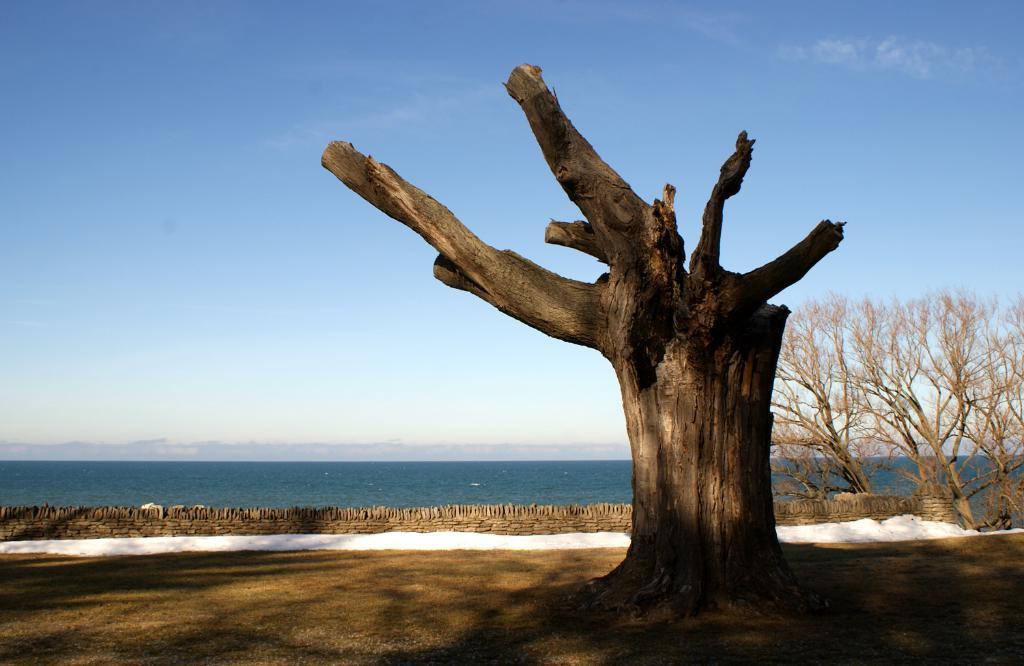What type of natural environment is depicted in the image? There is an ocean in the image. What type of vegetation can be seen in the image? There are trees in the image. Can you describe a specific part of a tree that is visible in the image? There is a tree trunk visible in the image. How much powder is on the tree trunk in the image? There is no powder present on the tree trunk in the image. Can you see the sister of the tree in the image? There is no mention of a sister tree or any other trees in the image besides the ones already mentioned. 